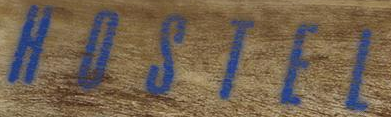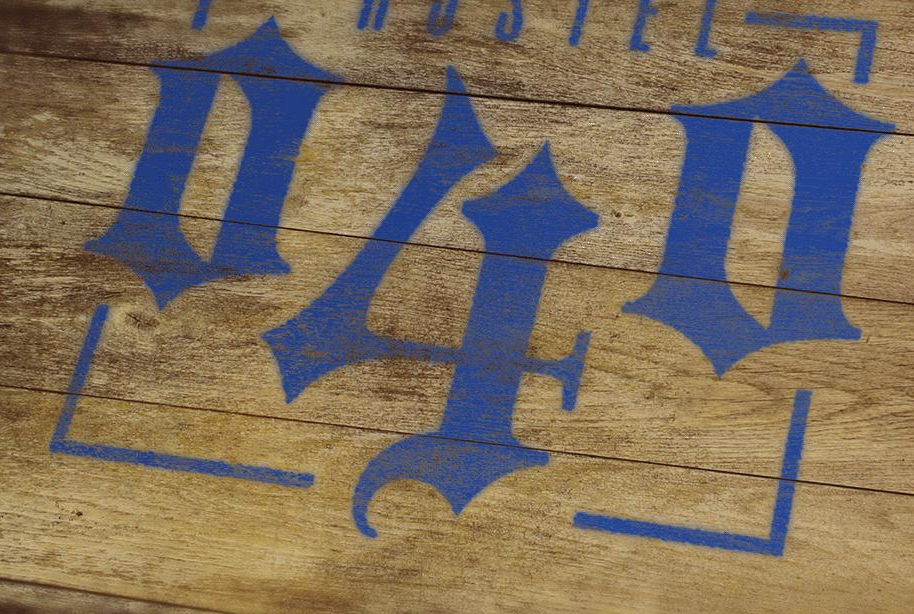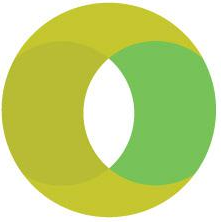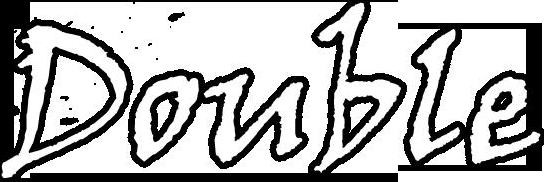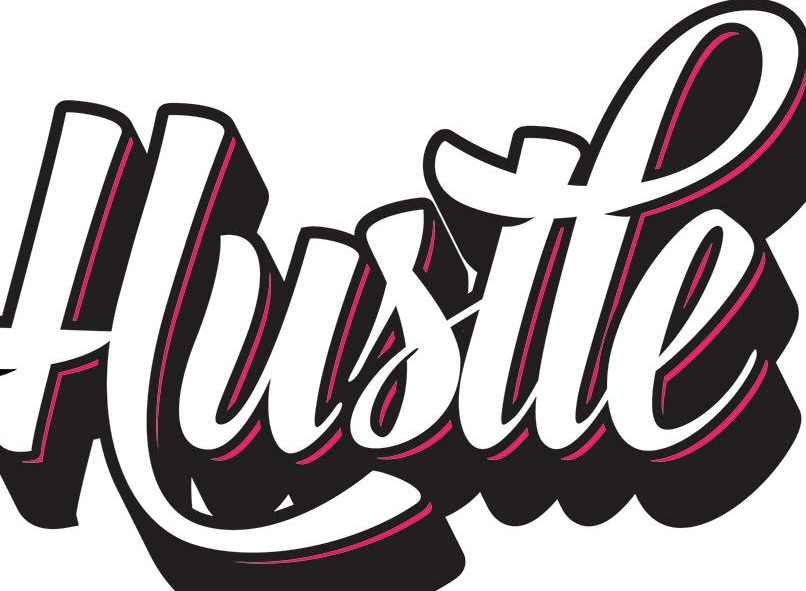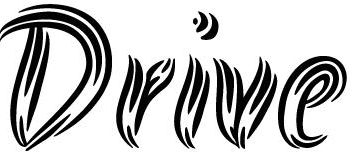Transcribe the words shown in these images in order, separated by a semicolon. HOSTEL; 040; O; Double; Hustle; Drive 